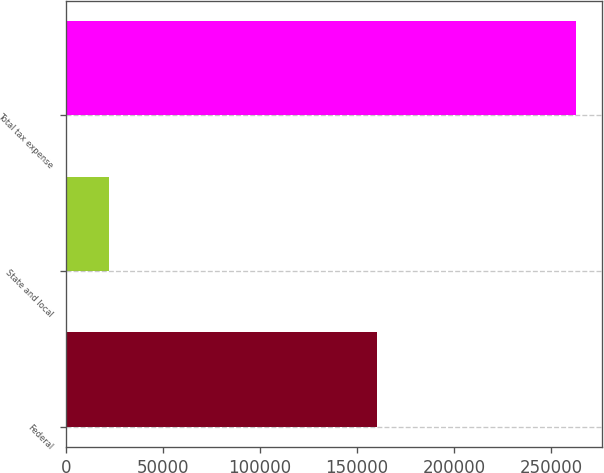<chart> <loc_0><loc_0><loc_500><loc_500><bar_chart><fcel>Federal<fcel>State and local<fcel>Total tax expense<nl><fcel>160235<fcel>22306<fcel>262968<nl></chart> 